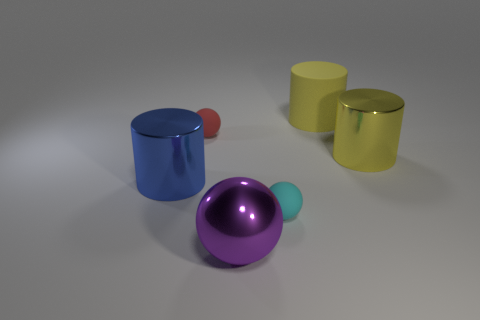There is a metal cylinder that is to the right of the shiny cylinder that is left of the tiny object to the right of the big purple metal ball; how big is it?
Keep it short and to the point. Large. There is a object that is on the left side of the cyan rubber ball and in front of the big blue metal thing; what is its size?
Your response must be concise. Large. What color is the big matte cylinder?
Your answer should be very brief. Yellow. How many cylinders are there?
Ensure brevity in your answer.  3. What number of metallic things have the same color as the big ball?
Keep it short and to the point. 0. There is a large yellow object behind the yellow metallic cylinder; does it have the same shape as the matte object on the left side of the purple sphere?
Your answer should be very brief. No. The large shiny thing that is in front of the cyan sphere that is to the right of the big object to the left of the large purple object is what color?
Give a very brief answer. Purple. What color is the rubber object that is in front of the red object?
Your answer should be very brief. Cyan. There is a sphere that is the same size as the blue cylinder; what is its color?
Your answer should be compact. Purple. Is the size of the blue shiny object the same as the yellow matte cylinder?
Keep it short and to the point. Yes. 